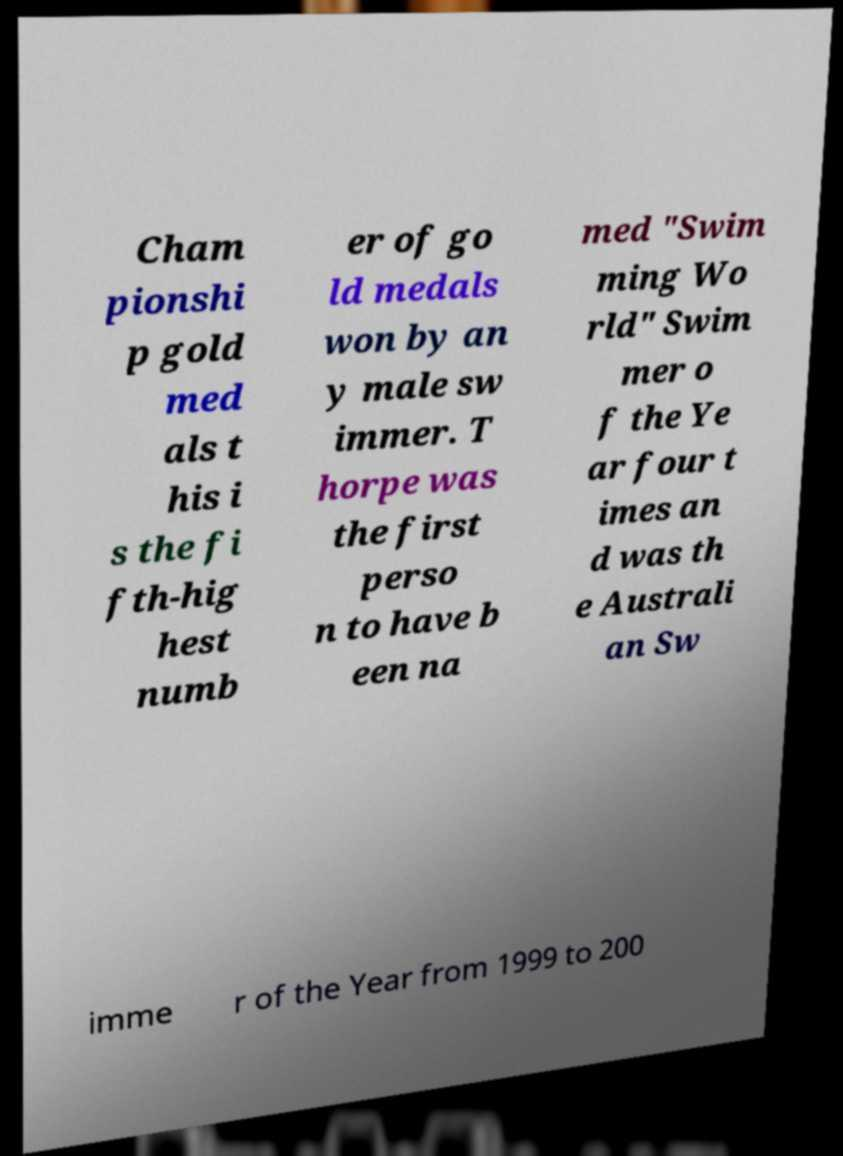There's text embedded in this image that I need extracted. Can you transcribe it verbatim? Cham pionshi p gold med als t his i s the fi fth-hig hest numb er of go ld medals won by an y male sw immer. T horpe was the first perso n to have b een na med "Swim ming Wo rld" Swim mer o f the Ye ar four t imes an d was th e Australi an Sw imme r of the Year from 1999 to 200 